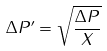Convert formula to latex. <formula><loc_0><loc_0><loc_500><loc_500>\Delta P ^ { \prime } = \sqrt { \frac { \Delta P } { X } }</formula> 